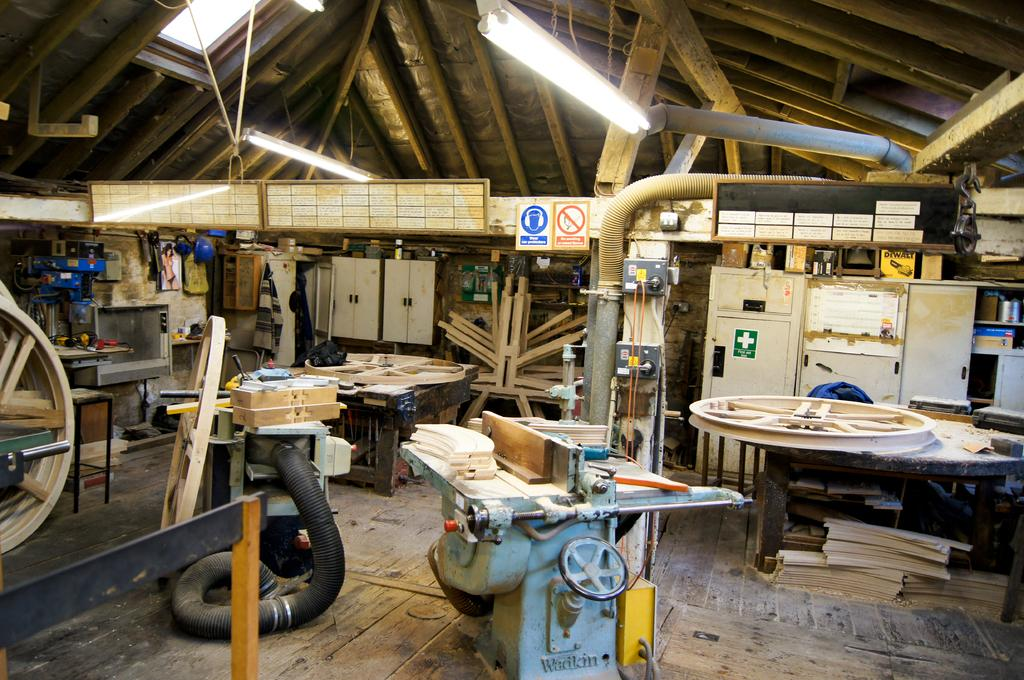What is the main object in the image? There is a machine in the image. What type of environment is depicted in the image? There are woods in the image. How much butter is on the hill in the image? There is no butter or hill present in the image; it features a machine in a wooded environment. 